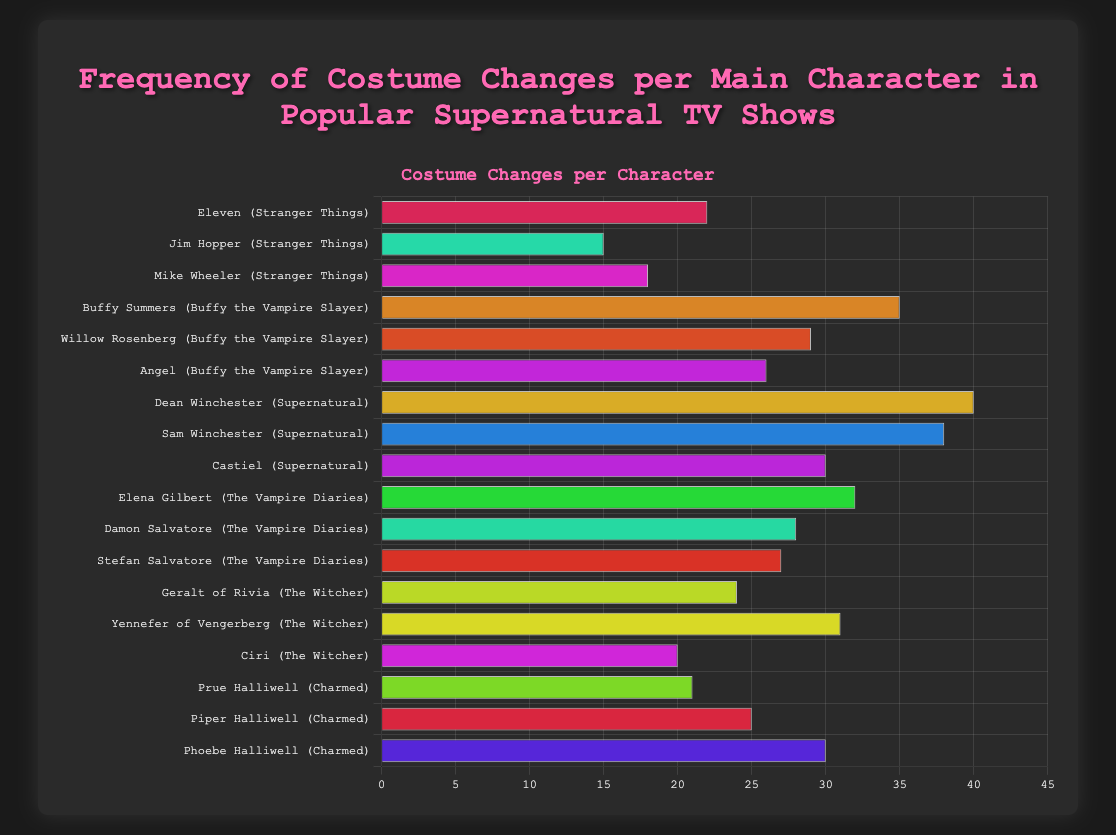Who has the highest number of costume changes among all characters? First, identify the character with the longest bar in the chart. Dean Winchester from "Supernatural" has the tallest bar, indicating he has the most costume changes.
Answer: Dean Winchester Which character has more costume changes, Elena Gilbert from "The Vampire Diaries" or Yennefer of Vengerberg from "The Witcher"? Compare the lengths of their respective bars. Elena Gilbert from "The Vampire Diaries" has 32 costume changes, and Yennefer of Vengerberg from "The Witcher" has 31 costume changes.
Answer: Elena Gilbert What is the total number of costume changes for Buffy Summers, Willow Rosenberg, and Angel from "Buffy the Vampire Slayer"? Sum their costume changes: Buffy Summers (35) + Willow Rosenberg (29) + Angel (26) = 90.
Answer: 90 Which show features a character with a lower number of costume changes: "Stranger Things" or "Charmed"? Contrast the lowest costume change figures from each show. "Stranger Things" has Jim Hopper with 15 changes, while "Charmed" has Prue Halliwell with 21 changes.
Answer: Stranger Things What is the average number of costume changes for the characters in "Supernatural"? Add their changes: Dean Winchester (40) + Sam Winchester (38) + Castiel (30) = 108. Divide by 3 (number of characters): 108/3 = 36.
Answer: 36 How many more costume changes does Castiel from "Supernatural" have compared to Prue Halliwell from "Charmed"? Subtract the number of changes for Prue Halliwell from Castiel's: Castiel (30) - Prue Halliwell (21) = 9.
Answer: 9 What is the difference in costume changes between the character with the highest number and the character with the lowest number across all shows? Identify the highest (Dean Winchester, 40) and the lowest (Jim Hopper, 15). Subtract the lowest from the highest: 40 - 15 = 25.
Answer: 25 Which character has a bar colored in greenish hue and what show are they from? Visually scan for a greenish hue bar, noting character and show name. Since the provided figure uses random colors, this would require actual visual inspection if rendered.
Answer: Visual Inspection Required 